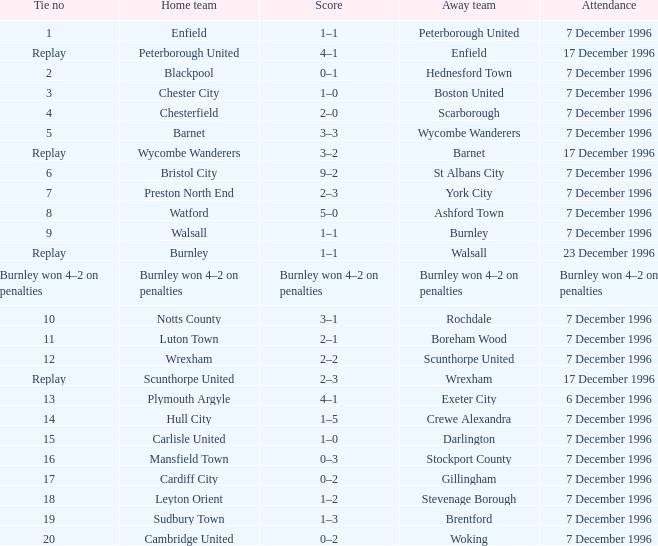What was the attendance for the home team of Walsall? 7 December 1996. 